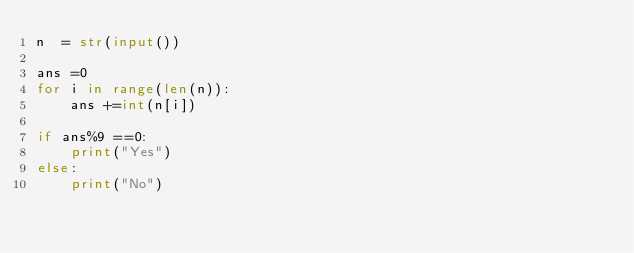Convert code to text. <code><loc_0><loc_0><loc_500><loc_500><_Python_>n  = str(input())

ans =0
for i in range(len(n)):
    ans +=int(n[i])

if ans%9 ==0:
    print("Yes")
else:
    print("No")</code> 